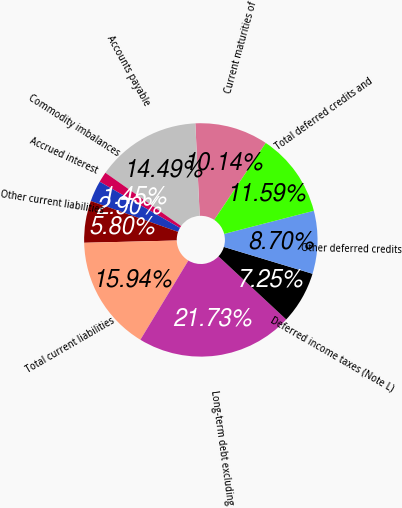Convert chart. <chart><loc_0><loc_0><loc_500><loc_500><pie_chart><fcel>Current maturities of<fcel>Accounts payable<fcel>Commodity imbalances<fcel>Accrued interest<fcel>Other current liabilities<fcel>Total current liabilities<fcel>Long-term debt excluding<fcel>Deferred income taxes (Note L)<fcel>Other deferred credits<fcel>Total deferred credits and<nl><fcel>10.14%<fcel>14.49%<fcel>1.45%<fcel>2.9%<fcel>5.8%<fcel>15.94%<fcel>21.73%<fcel>7.25%<fcel>8.7%<fcel>11.59%<nl></chart> 